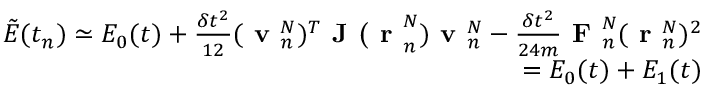<formula> <loc_0><loc_0><loc_500><loc_500>\begin{array} { r } { \tilde { E } ( t _ { n } ) \simeq E _ { 0 } ( t ) + \frac { \delta t ^ { 2 } } { 1 2 } ( v _ { n } ^ { N } ) ^ { T } J ( r _ { n } ^ { N } ) v _ { n } ^ { N } - \frac { \delta t ^ { 2 } } { 2 4 m } F _ { n } ^ { N } ( r _ { n } ^ { N } ) ^ { 2 } } \\ { = E _ { 0 } ( t ) + E _ { 1 } ( t ) } \end{array}</formula> 